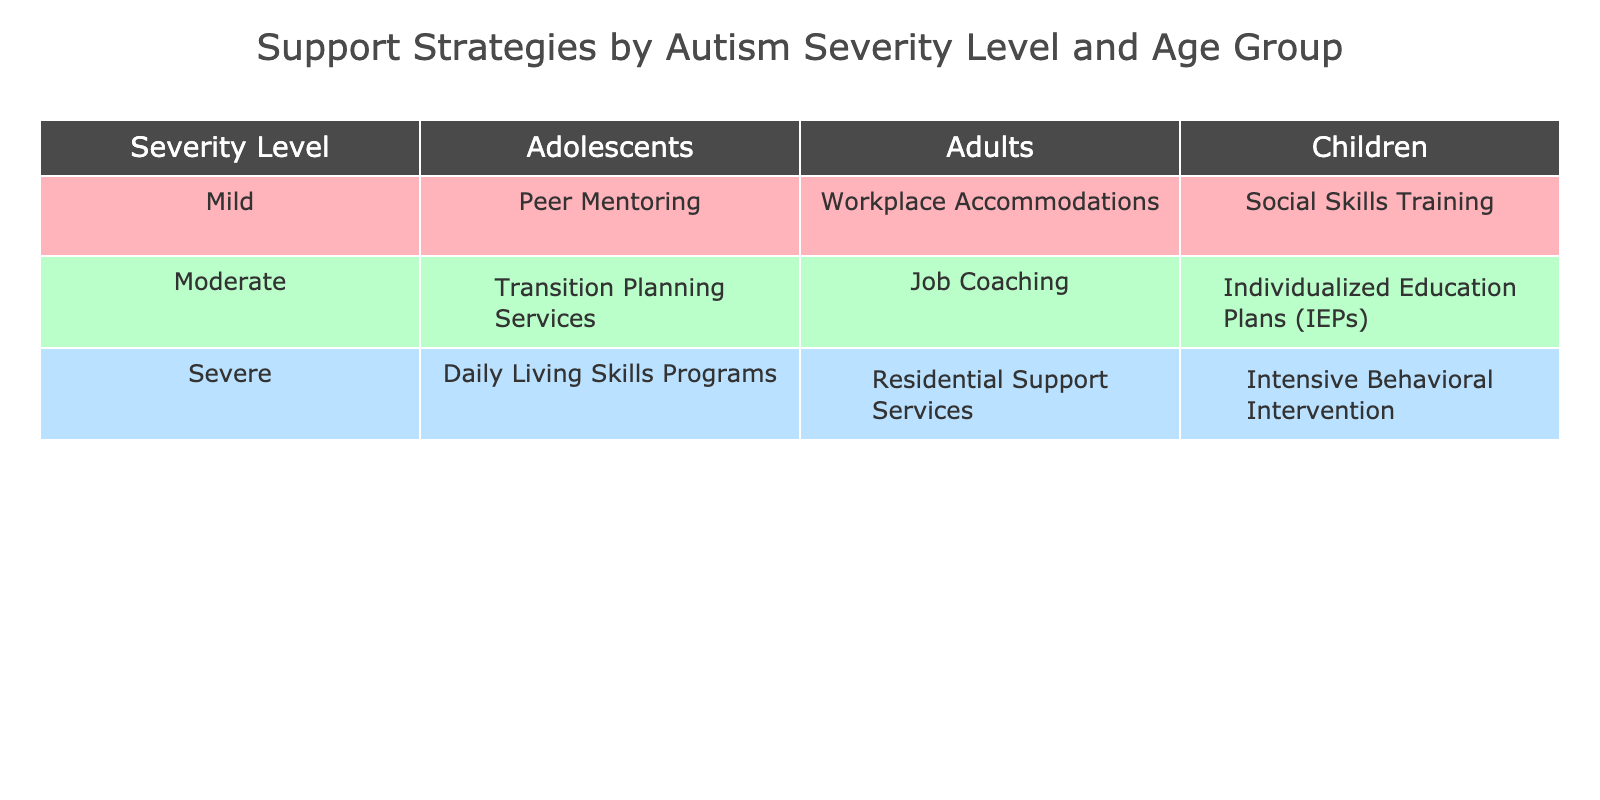What support strategy is provided for adults with a severe level of autism? In the table, locate the row corresponding to the "Severe" severity level and then look under the "Adults" column. The support strategy listed is "Residential Support Services."
Answer: Residential Support Services What is the support strategy for children with moderate autism? For the "Moderate" severity level, check the "Children" column. The support strategy noted there is "Individualized Education Plans (IEPs)."
Answer: Individualized Education Plans (IEPs) Are there any support strategies listed for adolescents with mild autism? Look under the "Mild" severity level and check the "Adolescents" column. The table reveals that there is a support strategy called "Peer Mentoring." Therefore, the answer is yes.
Answer: Yes How many total unique support strategies are listed in the table? Count the distinct support strategies across all rows. They are: Social Skills Training, Peer Mentoring, Workplace Accommodations, Individualized Education Plans (IEPs), Transition Planning Services, Job Coaching, Intensive Behavioral Intervention, Daily Living Skills Programs, and Residential Support Services. This totals to 9 unique strategies.
Answer: 9 Which severity level has the most diverse range of support strategies based on age groups? The "Moderate" severity level includes support strategies for Children, Adolescents, and Adults (Total: 3). The "Mild" severity level has strategies for Children, Adolescents, and Adults (Total: 3). The "Severe" level only has strategies for Children, Adolescents, and Adults as well (Total: 3). Therefore, all severity levels have an equal range of support strategies based on age groups.
Answer: All severity levels What is the support strategy for adults with moderate autism? Check the "Moderate" severity level and look under the "Adults" column. The strategy listed is "Job Coaching."
Answer: Job Coaching Is "Intensive Behavioral Intervention" used for adults? The table shows "Intensive Behavioral Intervention" is listed only under the "Children" age group within the "Severe" severity level. Thus, the answer is no.
Answer: No What is the average number of different support strategies across age groups for each severity level? Each severity level has 3 age groups (Children, Adolescents, and Adults) with a total of 9 support strategies divided among them. Since there are 3 severity levels, the average is 9 strategies divided by 3 severity levels, resulting in an average of 3 strategies per level.
Answer: 3 Are there specific support strategies for children and adolescents at each severity level? The table confirms that for each severity level (Mild, Moderate, Severe), there is a specified support strategy for both children and adolescents. Thus, the answer is yes.
Answer: Yes What is the only support strategy listed for adolescents with severe autism? For the "Severe" level, find the "Adolescents" column. The support strategy there is "Daily Living Skills Programs."
Answer: Daily Living Skills Programs 